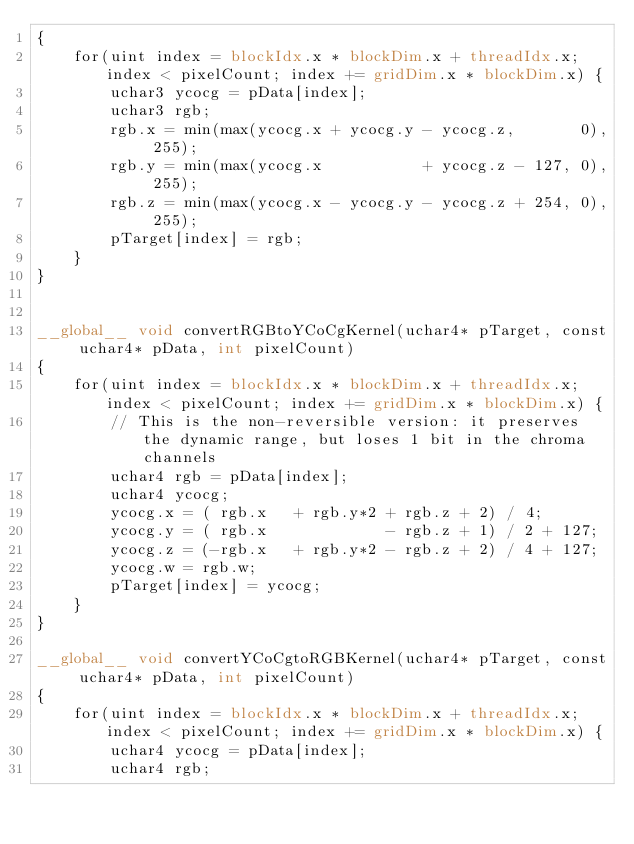<code> <loc_0><loc_0><loc_500><loc_500><_Cuda_>{
    for(uint index = blockIdx.x * blockDim.x + threadIdx.x; index < pixelCount; index += gridDim.x * blockDim.x) {
        uchar3 ycocg = pData[index];
        uchar3 rgb;
        rgb.x = min(max(ycocg.x + ycocg.y - ycocg.z,       0), 255);
        rgb.y = min(max(ycocg.x           + ycocg.z - 127, 0), 255);
        rgb.z = min(max(ycocg.x - ycocg.y - ycocg.z + 254, 0), 255);
        pTarget[index] = rgb;
    }
}


__global__ void convertRGBtoYCoCgKernel(uchar4* pTarget, const uchar4* pData, int pixelCount)
{
    for(uint index = blockIdx.x * blockDim.x + threadIdx.x; index < pixelCount; index += gridDim.x * blockDim.x) {
        // This is the non-reversible version: it preserves the dynamic range, but loses 1 bit in the chroma channels
        uchar4 rgb = pData[index];
        uchar4 ycocg;
        ycocg.x = ( rgb.x   + rgb.y*2 + rgb.z + 2) / 4;
        ycocg.y = ( rgb.x             - rgb.z + 1) / 2 + 127;
        ycocg.z = (-rgb.x   + rgb.y*2 - rgb.z + 2) / 4 + 127;
        ycocg.w = rgb.w;
        pTarget[index] = ycocg;
    }
}

__global__ void convertYCoCgtoRGBKernel(uchar4* pTarget, const uchar4* pData, int pixelCount)
{
    for(uint index = blockIdx.x * blockDim.x + threadIdx.x; index < pixelCount; index += gridDim.x * blockDim.x) {
        uchar4 ycocg = pData[index];
        uchar4 rgb;</code> 